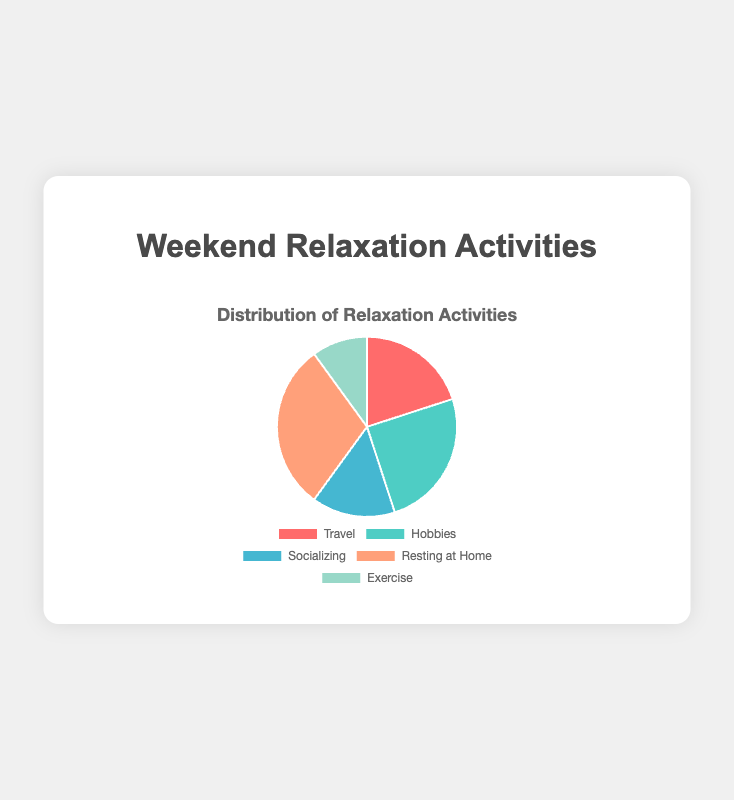What activity takes up the largest percentage of the weekend relaxation activities? The activity with the largest percentage is visually the biggest slice in the pie chart. Here, it is 'Resting at Home' with 30%.
Answer: Resting at Home What percentage of the pie chart represents Hobbies and Exercise combined? Hobbies occupy 25% and Exercise occupies 10%. Combining these percentages is a simple addition: 25% + 10% = 35%.
Answer: 35% Is the combined percentage of Travel and Socializing greater than the percentage of Resting at Home? Travel is 20% and Socializing is 15%, making their combined percentage 20% + 15% = 35%. Resting at Home is 30%, so 35% is greater than 30%.
Answer: Yes Rank the activities from most to least based on their percentage. By visual inspection: Resting at Home (30%), Hobbies (25%), Travel (20%), Socializing (15%), and Exercise (10%).
Answer: Resting at Home, Hobbies, Travel, Socializing, Exercise What is the sum of the percentages for Socializing and Exercise? Socializing is 15% and Exercise is 10%. Adding these gives 15% + 10% = 25%.
Answer: 25% Which activity occupies the smallest portion of the pie chart? The smallest portion of the pie chart is the smallest slice, which is Exercise at 10%.
Answer: Exercise How much more is the percentage of Hobbies compared to Socializing? Hobbies have 25% and Socializing has 15%. The difference is 25% - 15% = 10%.
Answer: 10% What is the average percentage of all the weekend relaxation activities? Add all percentages: 20% + 25% + 15% + 30% + 10% = 100%. Divide by the number of activities (5): 100% / 5 = 20%.
Answer: 20% 